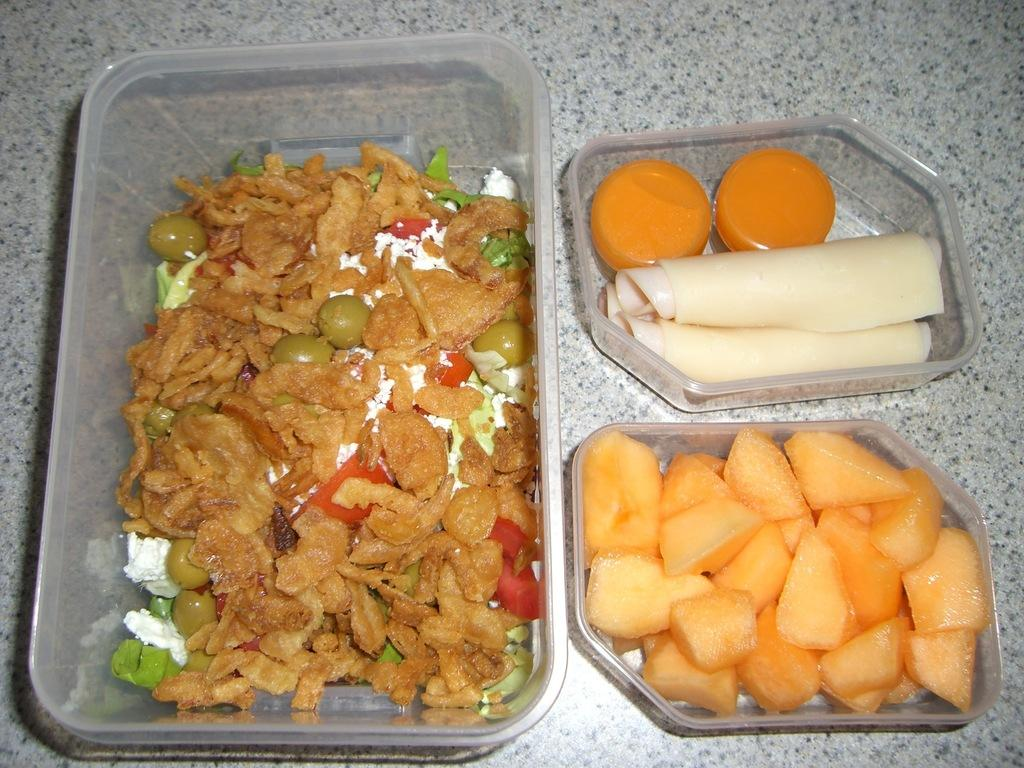What type of objects can be seen in the image? There are food items and a bowl in the image. Where are the food items and bowl located? The food items and bowl are kept on a surface. Can you describe the food items in the image? Unfortunately, the specific food items cannot be identified from the provided facts. What thoughts are the food items having in the image? Food items do not have thoughts, as they are inanimate objects. 